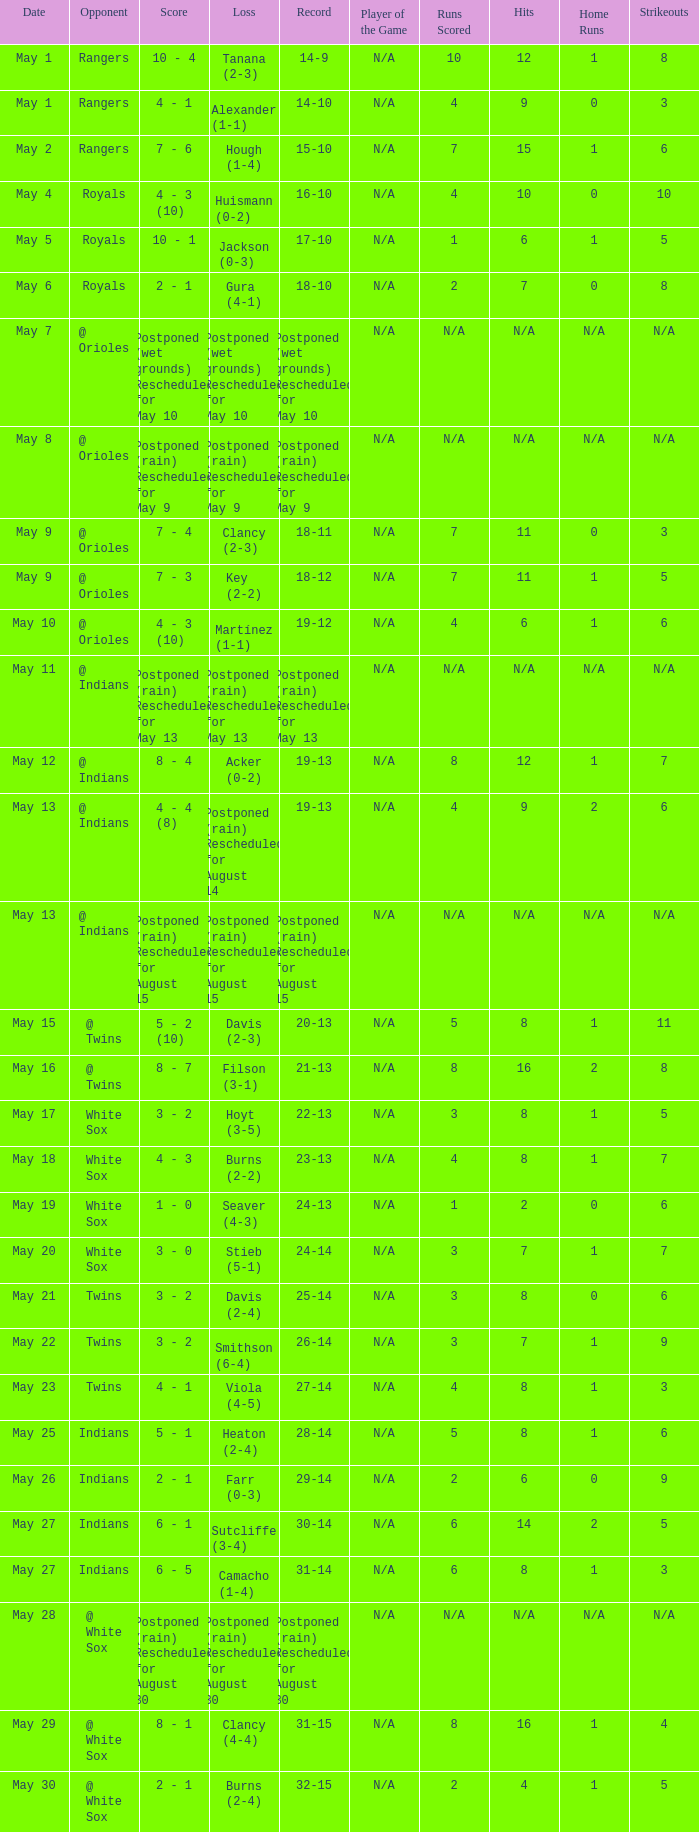What was the record at the game against the Indians with a loss of Camacho (1-4)? 31-14. 